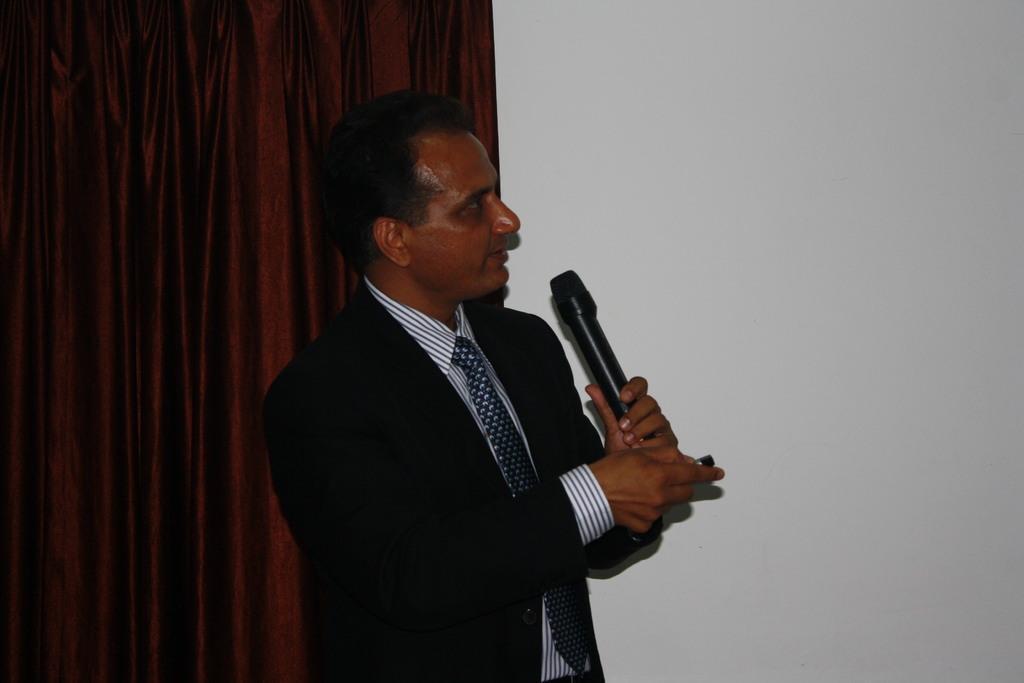Can you describe this image briefly? In the center of the picture a person is standing holding a microphone, he is talking. On the left there is a red color curtain. On the right there is a white wall. 